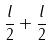Convert formula to latex. <formula><loc_0><loc_0><loc_500><loc_500>\frac { l } { 2 } + \frac { l } { 2 }</formula> 